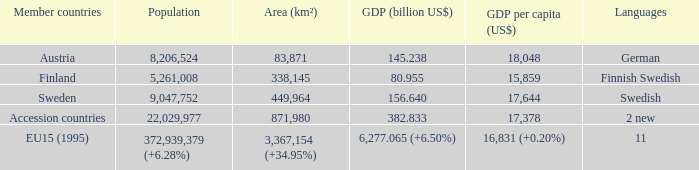Specify the zone for german. 83871.0. 